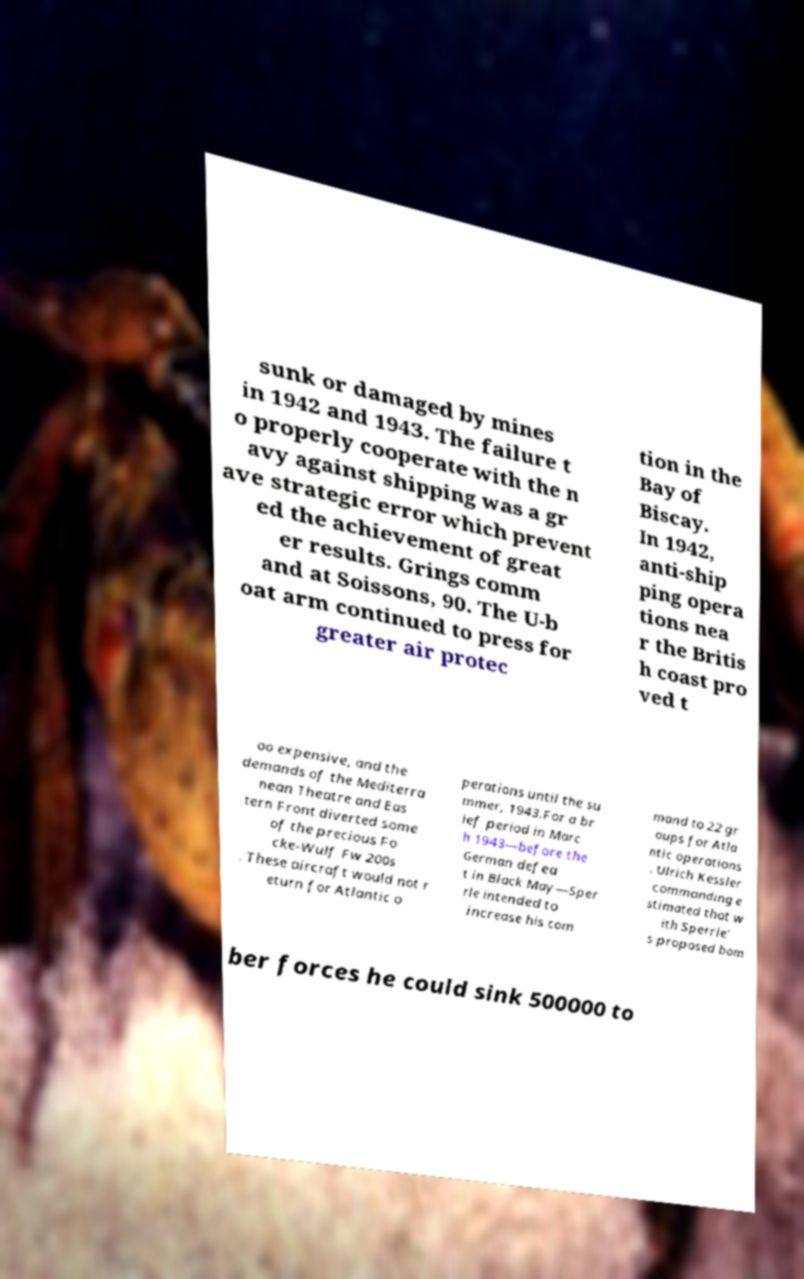What messages or text are displayed in this image? I need them in a readable, typed format. sunk or damaged by mines in 1942 and 1943. The failure t o properly cooperate with the n avy against shipping was a gr ave strategic error which prevent ed the achievement of great er results. Grings comm and at Soissons, 90. The U-b oat arm continued to press for greater air protec tion in the Bay of Biscay. In 1942, anti-ship ping opera tions nea r the Britis h coast pro ved t oo expensive, and the demands of the Mediterra nean Theatre and Eas tern Front diverted some of the precious Fo cke-Wulf Fw 200s . These aircraft would not r eturn for Atlantic o perations until the su mmer, 1943.For a br ief period in Marc h 1943—before the German defea t in Black May—Sper rle intended to increase his com mand to 22 gr oups for Atla ntic operations . Ulrich Kessler commanding e stimated that w ith Sperrle' s proposed bom ber forces he could sink 500000 to 